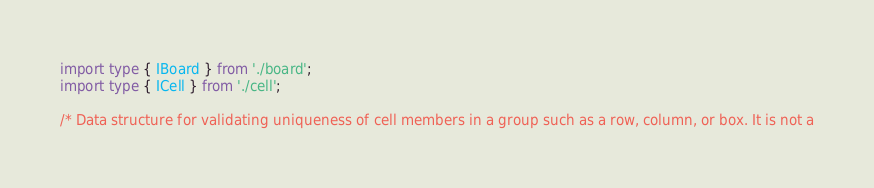Convert code to text. <code><loc_0><loc_0><loc_500><loc_500><_TypeScript_>import type { IBoard } from './board';
import type { ICell } from './cell'; 

/* Data structure for validating uniqueness of cell members in a group such as a row, column, or box. It is not a</code> 